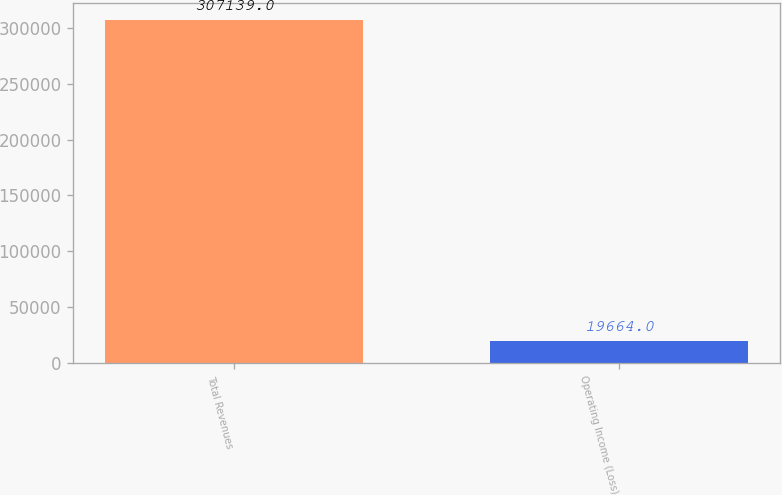<chart> <loc_0><loc_0><loc_500><loc_500><bar_chart><fcel>Total Revenues<fcel>Operating Income (Loss)<nl><fcel>307139<fcel>19664<nl></chart> 